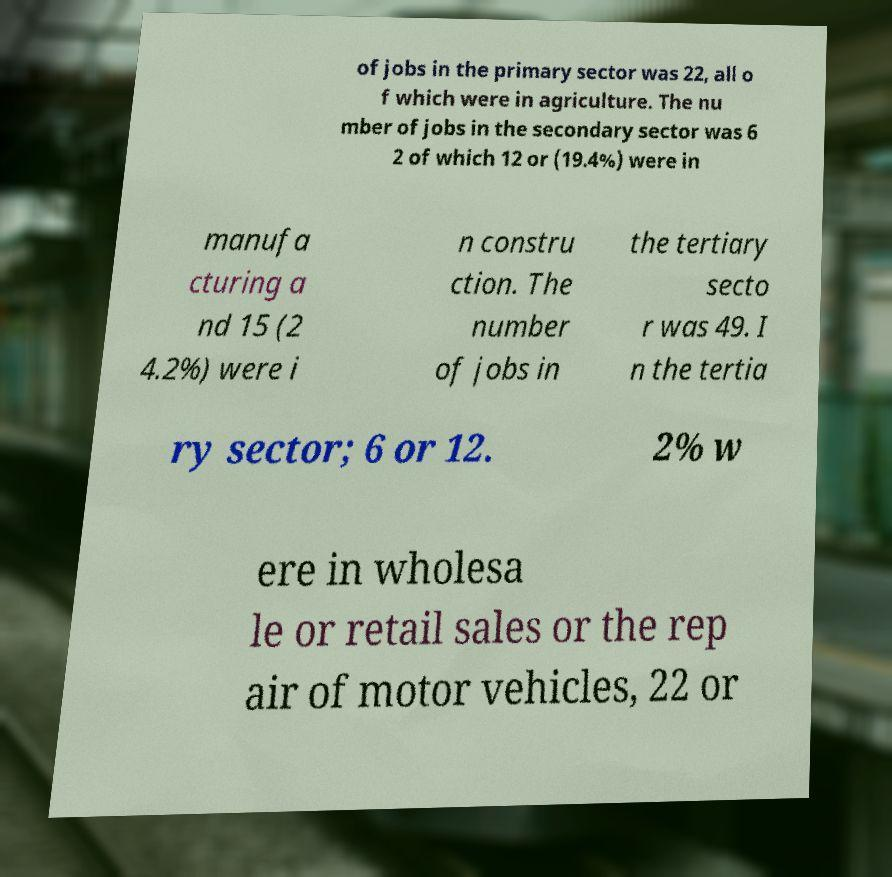What messages or text are displayed in this image? I need them in a readable, typed format. of jobs in the primary sector was 22, all o f which were in agriculture. The nu mber of jobs in the secondary sector was 6 2 of which 12 or (19.4%) were in manufa cturing a nd 15 (2 4.2%) were i n constru ction. The number of jobs in the tertiary secto r was 49. I n the tertia ry sector; 6 or 12. 2% w ere in wholesa le or retail sales or the rep air of motor vehicles, 22 or 